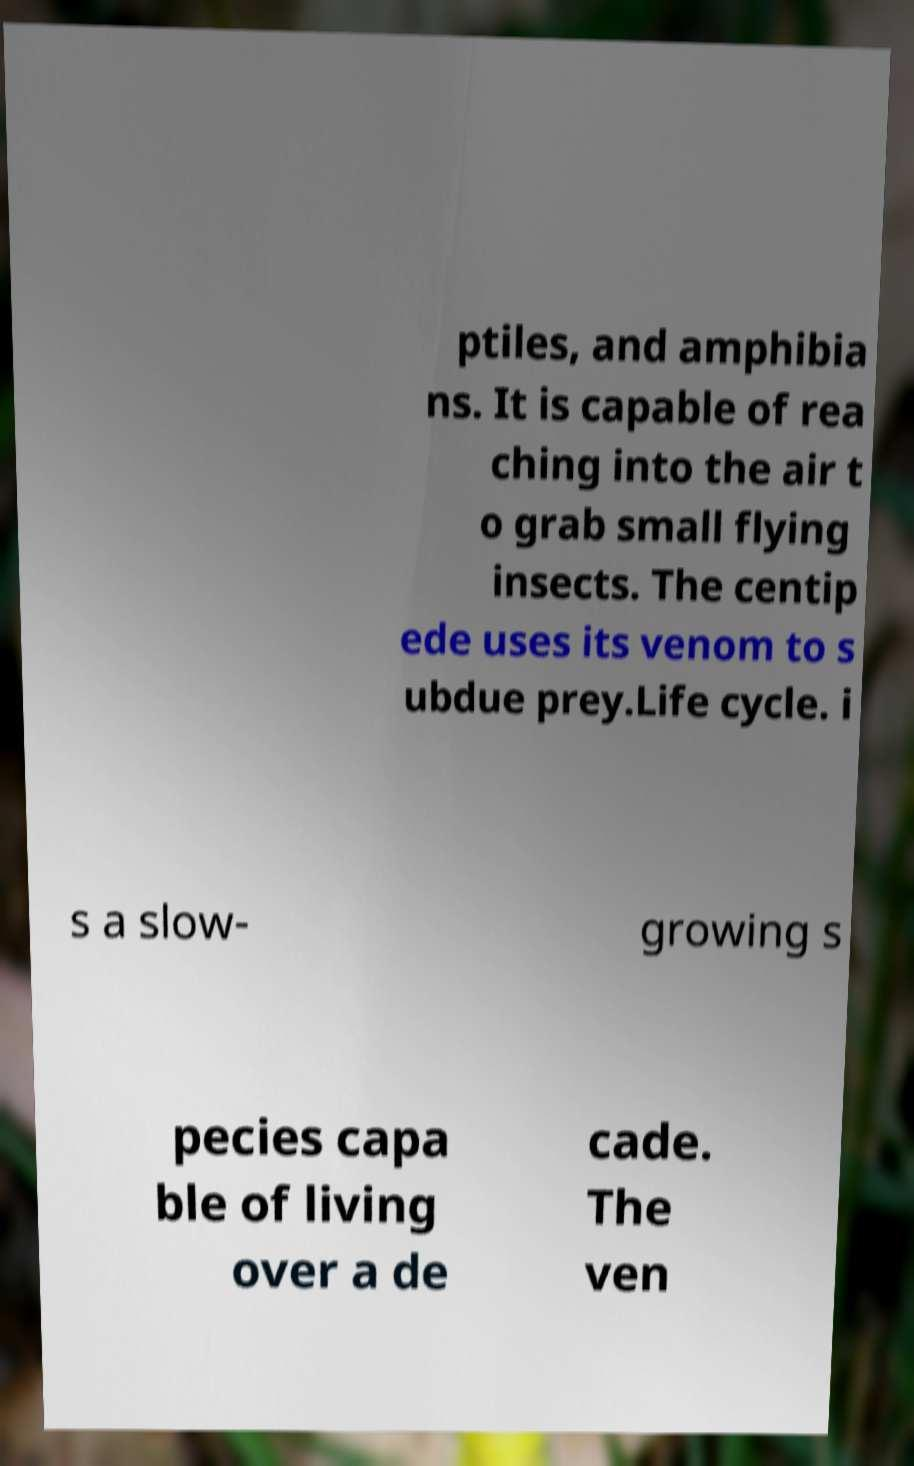Could you assist in decoding the text presented in this image and type it out clearly? ptiles, and amphibia ns. It is capable of rea ching into the air t o grab small flying insects. The centip ede uses its venom to s ubdue prey.Life cycle. i s a slow- growing s pecies capa ble of living over a de cade. The ven 